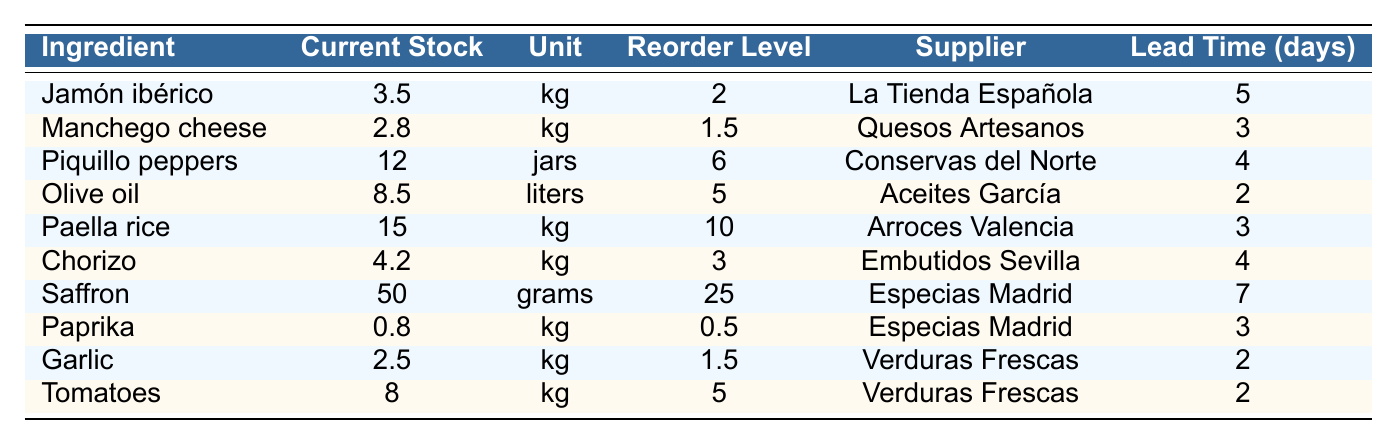What is the current stock of Jamón ibérico? The table shows that the current stock of Jamón ibérico is 3.5 kg.
Answer: 3.5 kg Which ingredient has the highest reorder level? The reorder levels listed show Saffron with the highest reorder level of 25 grams.
Answer: Saffron Is the current stock of Paprika below its reorder level? Paprika has a current stock of 0.8 kg and a reorder level of 0.5 kg, so it is indeed below its reorder level.
Answer: Yes What is the current stock of Piquillo peppers and how does it compare to its reorder level? Piquillo peppers have a current stock of 12 jars, which is above the reorder level of 6 jars.
Answer: Above its reorder level How many liters of Olive oil do we currently have, and is it above the reorder level? The current stock of Olive oil is 8.5 liters, which exceeds its reorder level of 5 liters.
Answer: Yes What is the total current stock (in kg) of all ingredients excluding Saffron? To find this, add the current stocks of all ingredients in kg except Saffron: 3.5 + 2.8 + 12 + 8.5 + 15 + 4.2 + 0.8 + 2.5 + 8 = 57.3 kg.
Answer: 57.3 kg Which ingredient has the shortest lead time and what is that time? Olive oil has the shortest lead time of 2 days.
Answer: 2 days Does the current stock of Chorizo meet its reorder level? Chorizo has a current stock of 4.2 kg and a reorder level of 3 kg, meaning it meets the reorder level.
Answer: Yes If we reorder all ingredients at their reorder levels, how much more stock will we have? Calculate the additional stock needed: (2 - 3.5) + (1.5 - 2.8) + (6 - 12) + (5 - 8.5) + (10 - 15) + (3 - 4.2) + (25 - 50) + (0.5 - 0.8) + (1.5 - 2.5) + (5 - 8) = -3.5 - 1.3 - 6 + -3.5 - 5 - 1.2 - 25 - 0.3 - 1 + -3 = -46.8 kg (implying a requirement for less stock than current).
Answer: -46.8 kg If we prioritize ingredients with the highest reorder levels, which one do we order first? The ingredient with the highest reorder level is Saffron at 25 grams, so it should be ordered first.
Answer: Saffron 